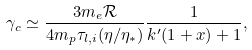<formula> <loc_0><loc_0><loc_500><loc_500>\gamma _ { c } \simeq \frac { 3 m _ { e } \mathcal { R } } { 4 m _ { p } \tau _ { l , i } ( \eta / \eta _ { * } ) } \frac { 1 } { k ^ { \prime } ( 1 + x ) + 1 } ,</formula> 